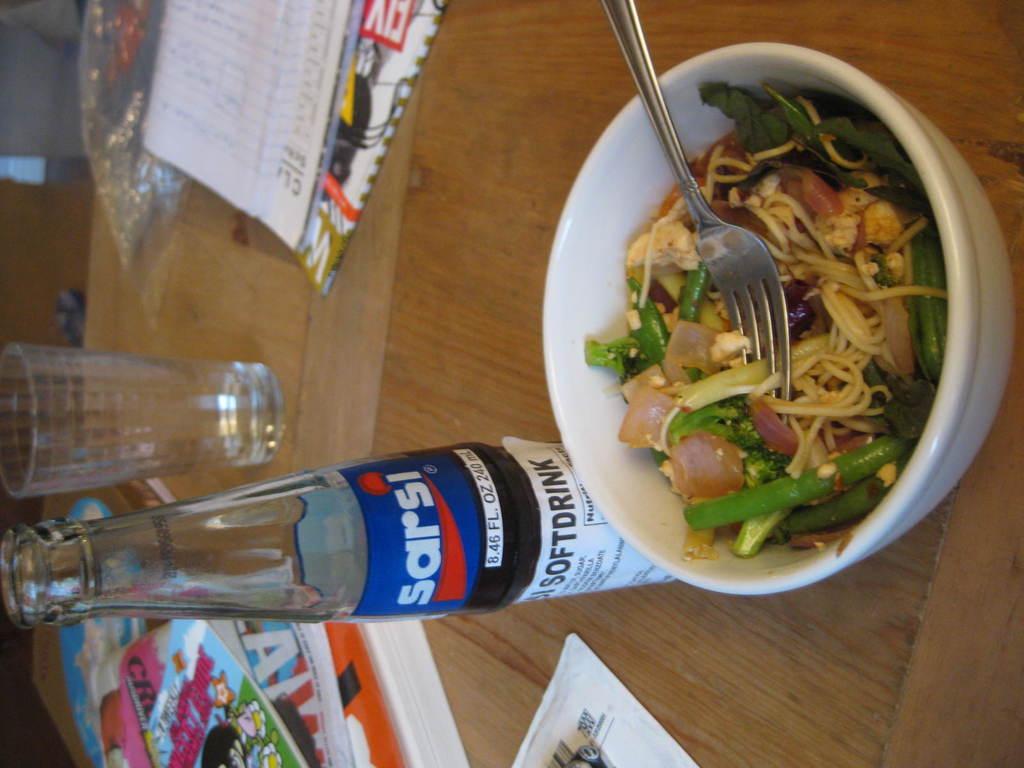How many fluid ounces are in the drink bottle?
Ensure brevity in your answer.  8.46. 